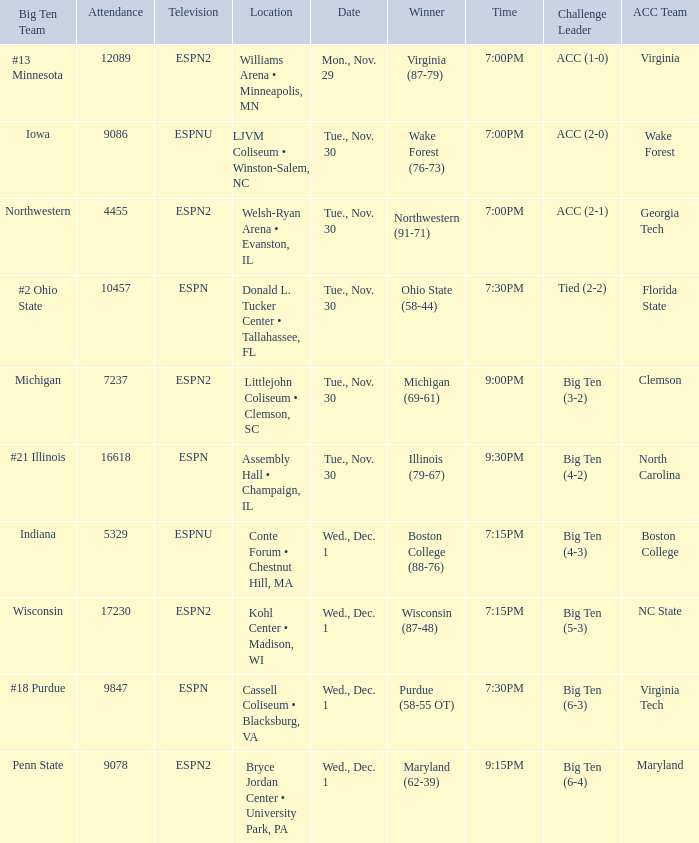Who were the challenge leaders of the games won by boston college (88-76)? Big Ten (4-3). 